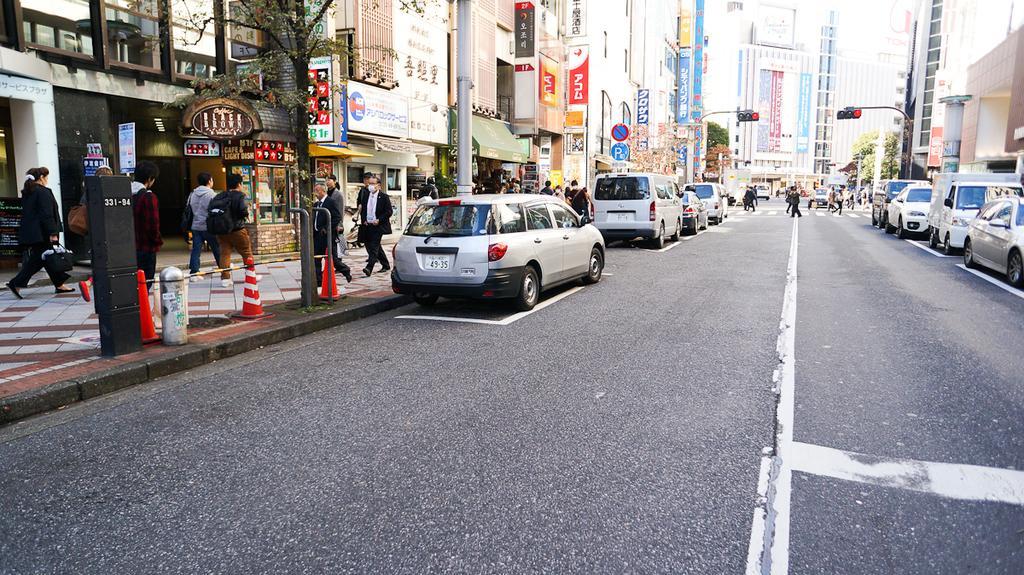In one or two sentences, can you explain what this image depicts? In this image we can see vehicles and few people are walking on the road. Here we can see poles, traffic signals, boards, hoardings, trees, traffic cones, buildings, and other objects. On the left side of the image we can see people walking on the footpath. 